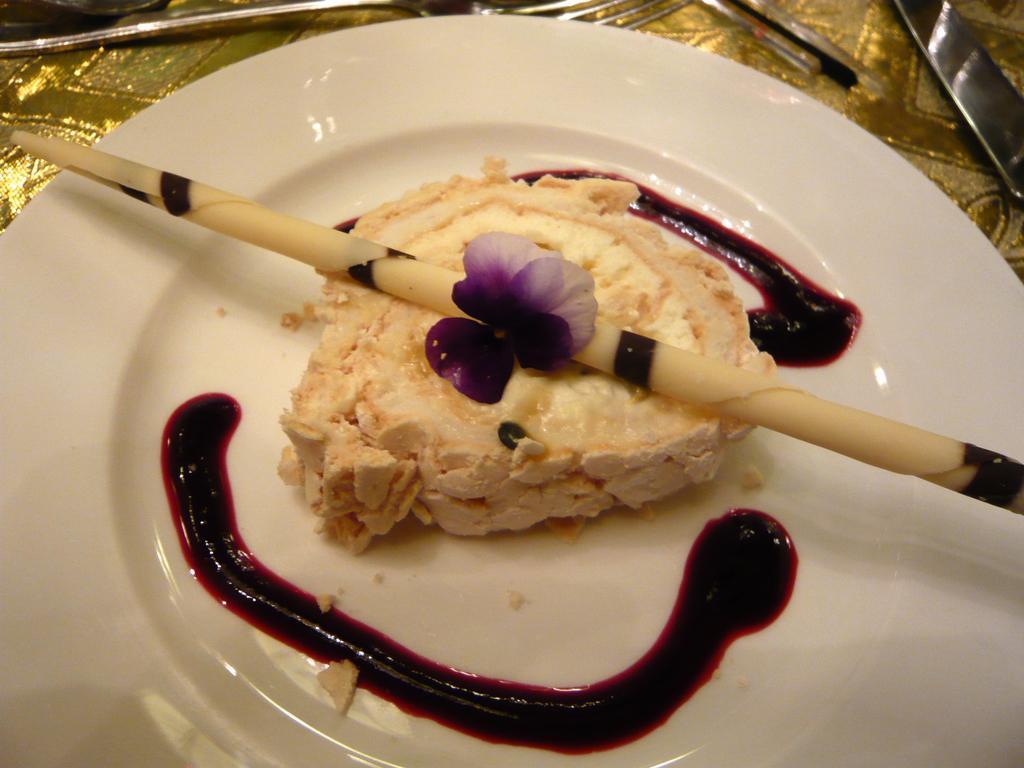Please provide a concise description of this image. In this image we can see the plate. Here we can see the pastry and sauce on the plate. Here we can see forks at the top. 